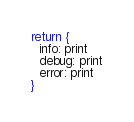<code> <loc_0><loc_0><loc_500><loc_500><_MoonScript_>return { 
  info: print
  debug: print
  error: print
}
</code> 